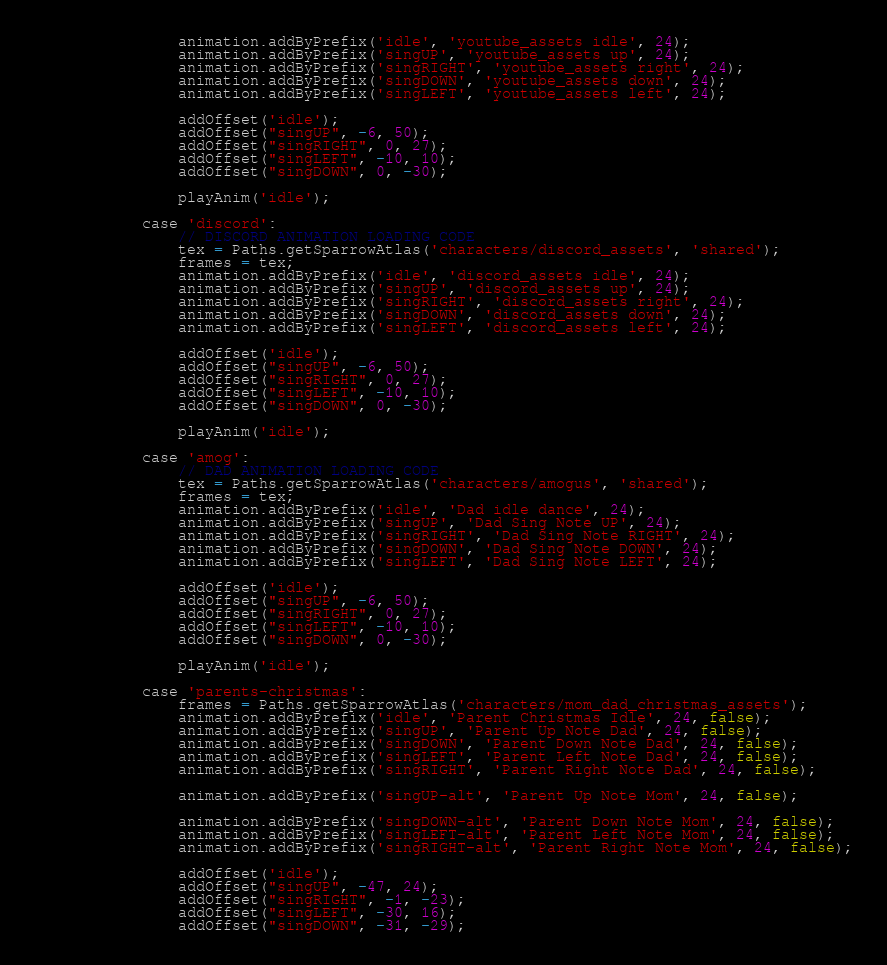<code> <loc_0><loc_0><loc_500><loc_500><_Haxe_>				animation.addByPrefix('idle', 'youtube_assets idle', 24);
				animation.addByPrefix('singUP', 'youtube_assets up', 24);
				animation.addByPrefix('singRIGHT', 'youtube_assets right', 24);
				animation.addByPrefix('singDOWN', 'youtube_assets down', 24);
				animation.addByPrefix('singLEFT', 'youtube_assets left', 24);

				addOffset('idle');
				addOffset("singUP", -6, 50);
				addOffset("singRIGHT", 0, 27);
				addOffset("singLEFT", -10, 10);
				addOffset("singDOWN", 0, -30);

				playAnim('idle');

			case 'discord':
				// DISCORD ANIMATION LOADING CODE
				tex = Paths.getSparrowAtlas('characters/discord_assets', 'shared');
				frames = tex;
				animation.addByPrefix('idle', 'discord_assets idle', 24);
				animation.addByPrefix('singUP', 'discord_assets up', 24);
				animation.addByPrefix('singRIGHT', 'discord_assets right', 24);
				animation.addByPrefix('singDOWN', 'discord_assets down', 24);
				animation.addByPrefix('singLEFT', 'discord_assets left', 24);

				addOffset('idle');
				addOffset("singUP", -6, 50);
				addOffset("singRIGHT", 0, 27);
				addOffset("singLEFT", -10, 10);
				addOffset("singDOWN", 0, -30);

				playAnim('idle');

		    case 'amog':
				// DAD ANIMATION LOADING CODE
				tex = Paths.getSparrowAtlas('characters/amogus', 'shared');
				frames = tex;
				animation.addByPrefix('idle', 'Dad idle dance', 24);
				animation.addByPrefix('singUP', 'Dad Sing Note UP', 24);
				animation.addByPrefix('singRIGHT', 'Dad Sing Note RIGHT', 24);
				animation.addByPrefix('singDOWN', 'Dad Sing Note DOWN', 24);
				animation.addByPrefix('singLEFT', 'Dad Sing Note LEFT', 24);

				addOffset('idle');
				addOffset("singUP", -6, 50);
				addOffset("singRIGHT", 0, 27);
				addOffset("singLEFT", -10, 10);
				addOffset("singDOWN", 0, -30);

				playAnim('idle');

			case 'parents-christmas':
				frames = Paths.getSparrowAtlas('characters/mom_dad_christmas_assets');
				animation.addByPrefix('idle', 'Parent Christmas Idle', 24, false);
				animation.addByPrefix('singUP', 'Parent Up Note Dad', 24, false);
				animation.addByPrefix('singDOWN', 'Parent Down Note Dad', 24, false);
				animation.addByPrefix('singLEFT', 'Parent Left Note Dad', 24, false);
				animation.addByPrefix('singRIGHT', 'Parent Right Note Dad', 24, false);

				animation.addByPrefix('singUP-alt', 'Parent Up Note Mom', 24, false);

				animation.addByPrefix('singDOWN-alt', 'Parent Down Note Mom', 24, false);
				animation.addByPrefix('singLEFT-alt', 'Parent Left Note Mom', 24, false);
				animation.addByPrefix('singRIGHT-alt', 'Parent Right Note Mom', 24, false);

				addOffset('idle');
				addOffset("singUP", -47, 24);
				addOffset("singRIGHT", -1, -23);
				addOffset("singLEFT", -30, 16);
				addOffset("singDOWN", -31, -29);</code> 